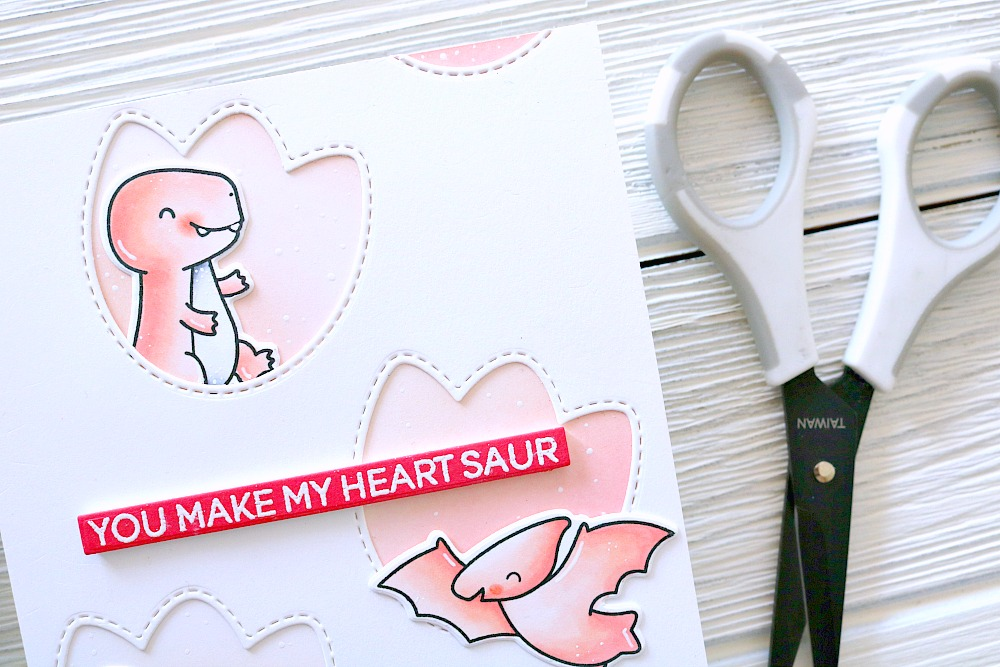What does the depiction of dinosaurs in a heart-shape frame signify in this card? The depiction of dinosaurs within heart-shaped frames playfully merges themes of enduring love with a touch of whimsy. Dinosaurs, often symbols of something ancient and enduring, cleverly juxtapose with the heart shapes, universal symbols of love. This combination might suggest a message of timeless affection, presenting it in a fun, unique manner that captures the heart in an unexpected way. 